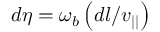<formula> <loc_0><loc_0><loc_500><loc_500>d \eta = \omega _ { b } \left ( d l / v _ { | | } \right )</formula> 